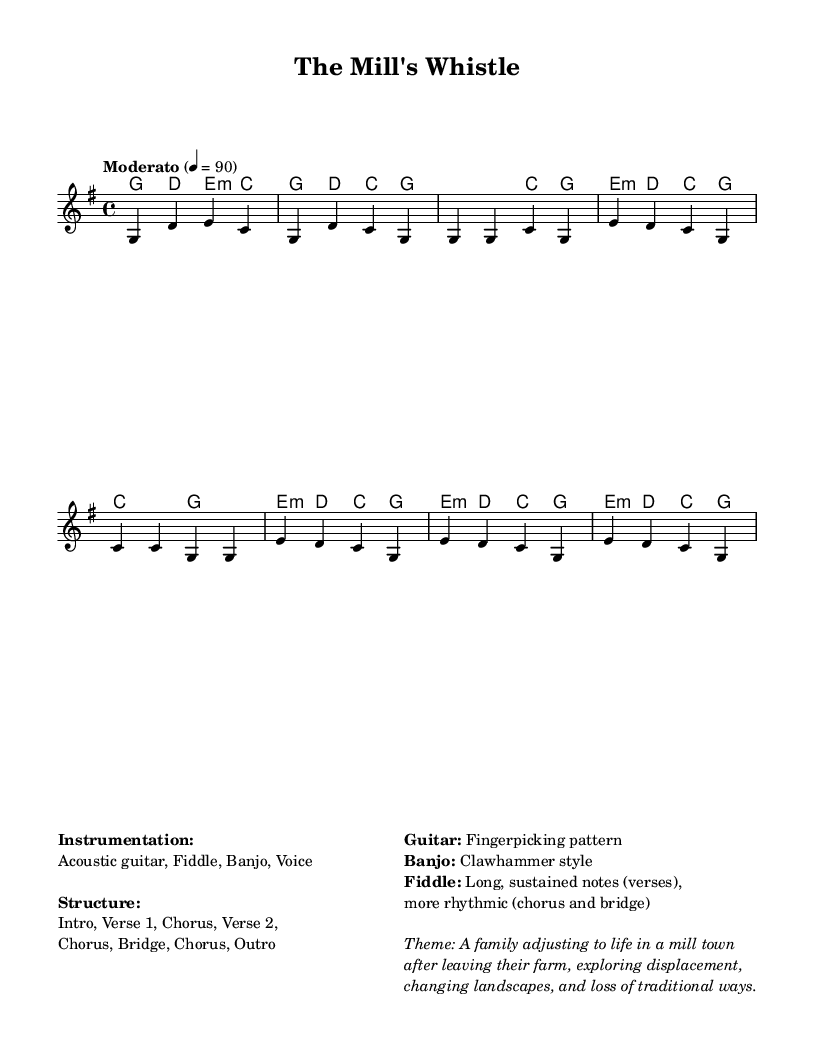What is the key signature of this music? The key signature is G major, which contains one sharp, F#. This can be identified by looking at the clef and the key signature indicated at the beginning of the score.
Answer: G major What is the time signature of this piece? The time signature is 4/4, as indicated at the beginning of the score, which means there are four beats in a measure, and the quarter note receives one beat.
Answer: 4/4 What is the tempo marking for this song? The tempo marking is "Moderato," which suggests a moderate speed for the performance. This can be found at the beginning of the score next to the tempo indication.
Answer: Moderato How many verses are indicated in the structure of the song? The structure mentions two verses (Verse 1 and Verse 2) along with other sections. This can be deduced from the section labels listed under the structure in the markup section.
Answer: 2 What primary theme does this folk song explore? The primary theme focuses on a family adjusting to life in a mill town, indicated in the thematic description provided in the markup section. This reflects the impact of industrialization on rural life.
Answer: A family adjusting to life in a mill town What style is used for the banjo in this piece? The banjo is styled in a "Clawhammer" technique, which is explicitly mentioned in the instrumentation details in the markup section. This technique is characteristic of various folk traditions.
Answer: Clawhammer How is the fiddle used differently in the verses compared to the chorus? In the verses, the fiddle is described as using long, sustained notes, while it takes on a more rhythmic role in the chorus, as detailed in the markup section under instrumentation.
Answer: Sustained notes (verses) and rhythmic (chorus) 